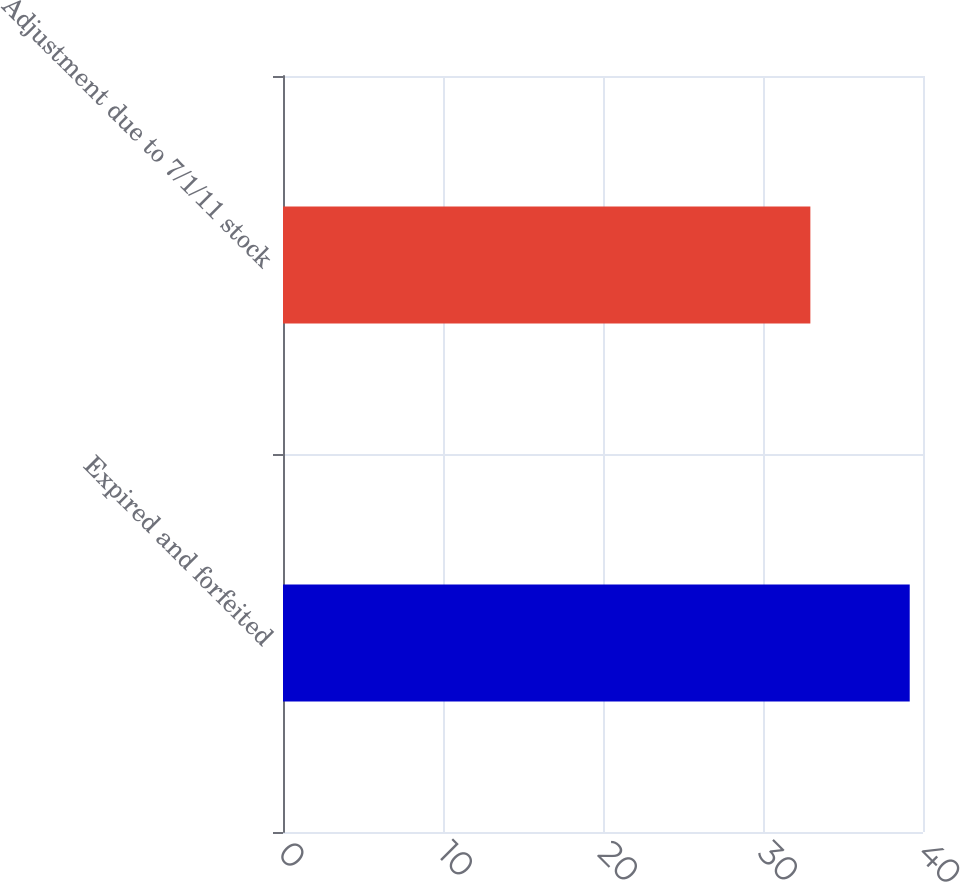Convert chart to OTSL. <chart><loc_0><loc_0><loc_500><loc_500><bar_chart><fcel>Expired and forfeited<fcel>Adjustment due to 7/1/11 stock<nl><fcel>39.17<fcel>32.96<nl></chart> 